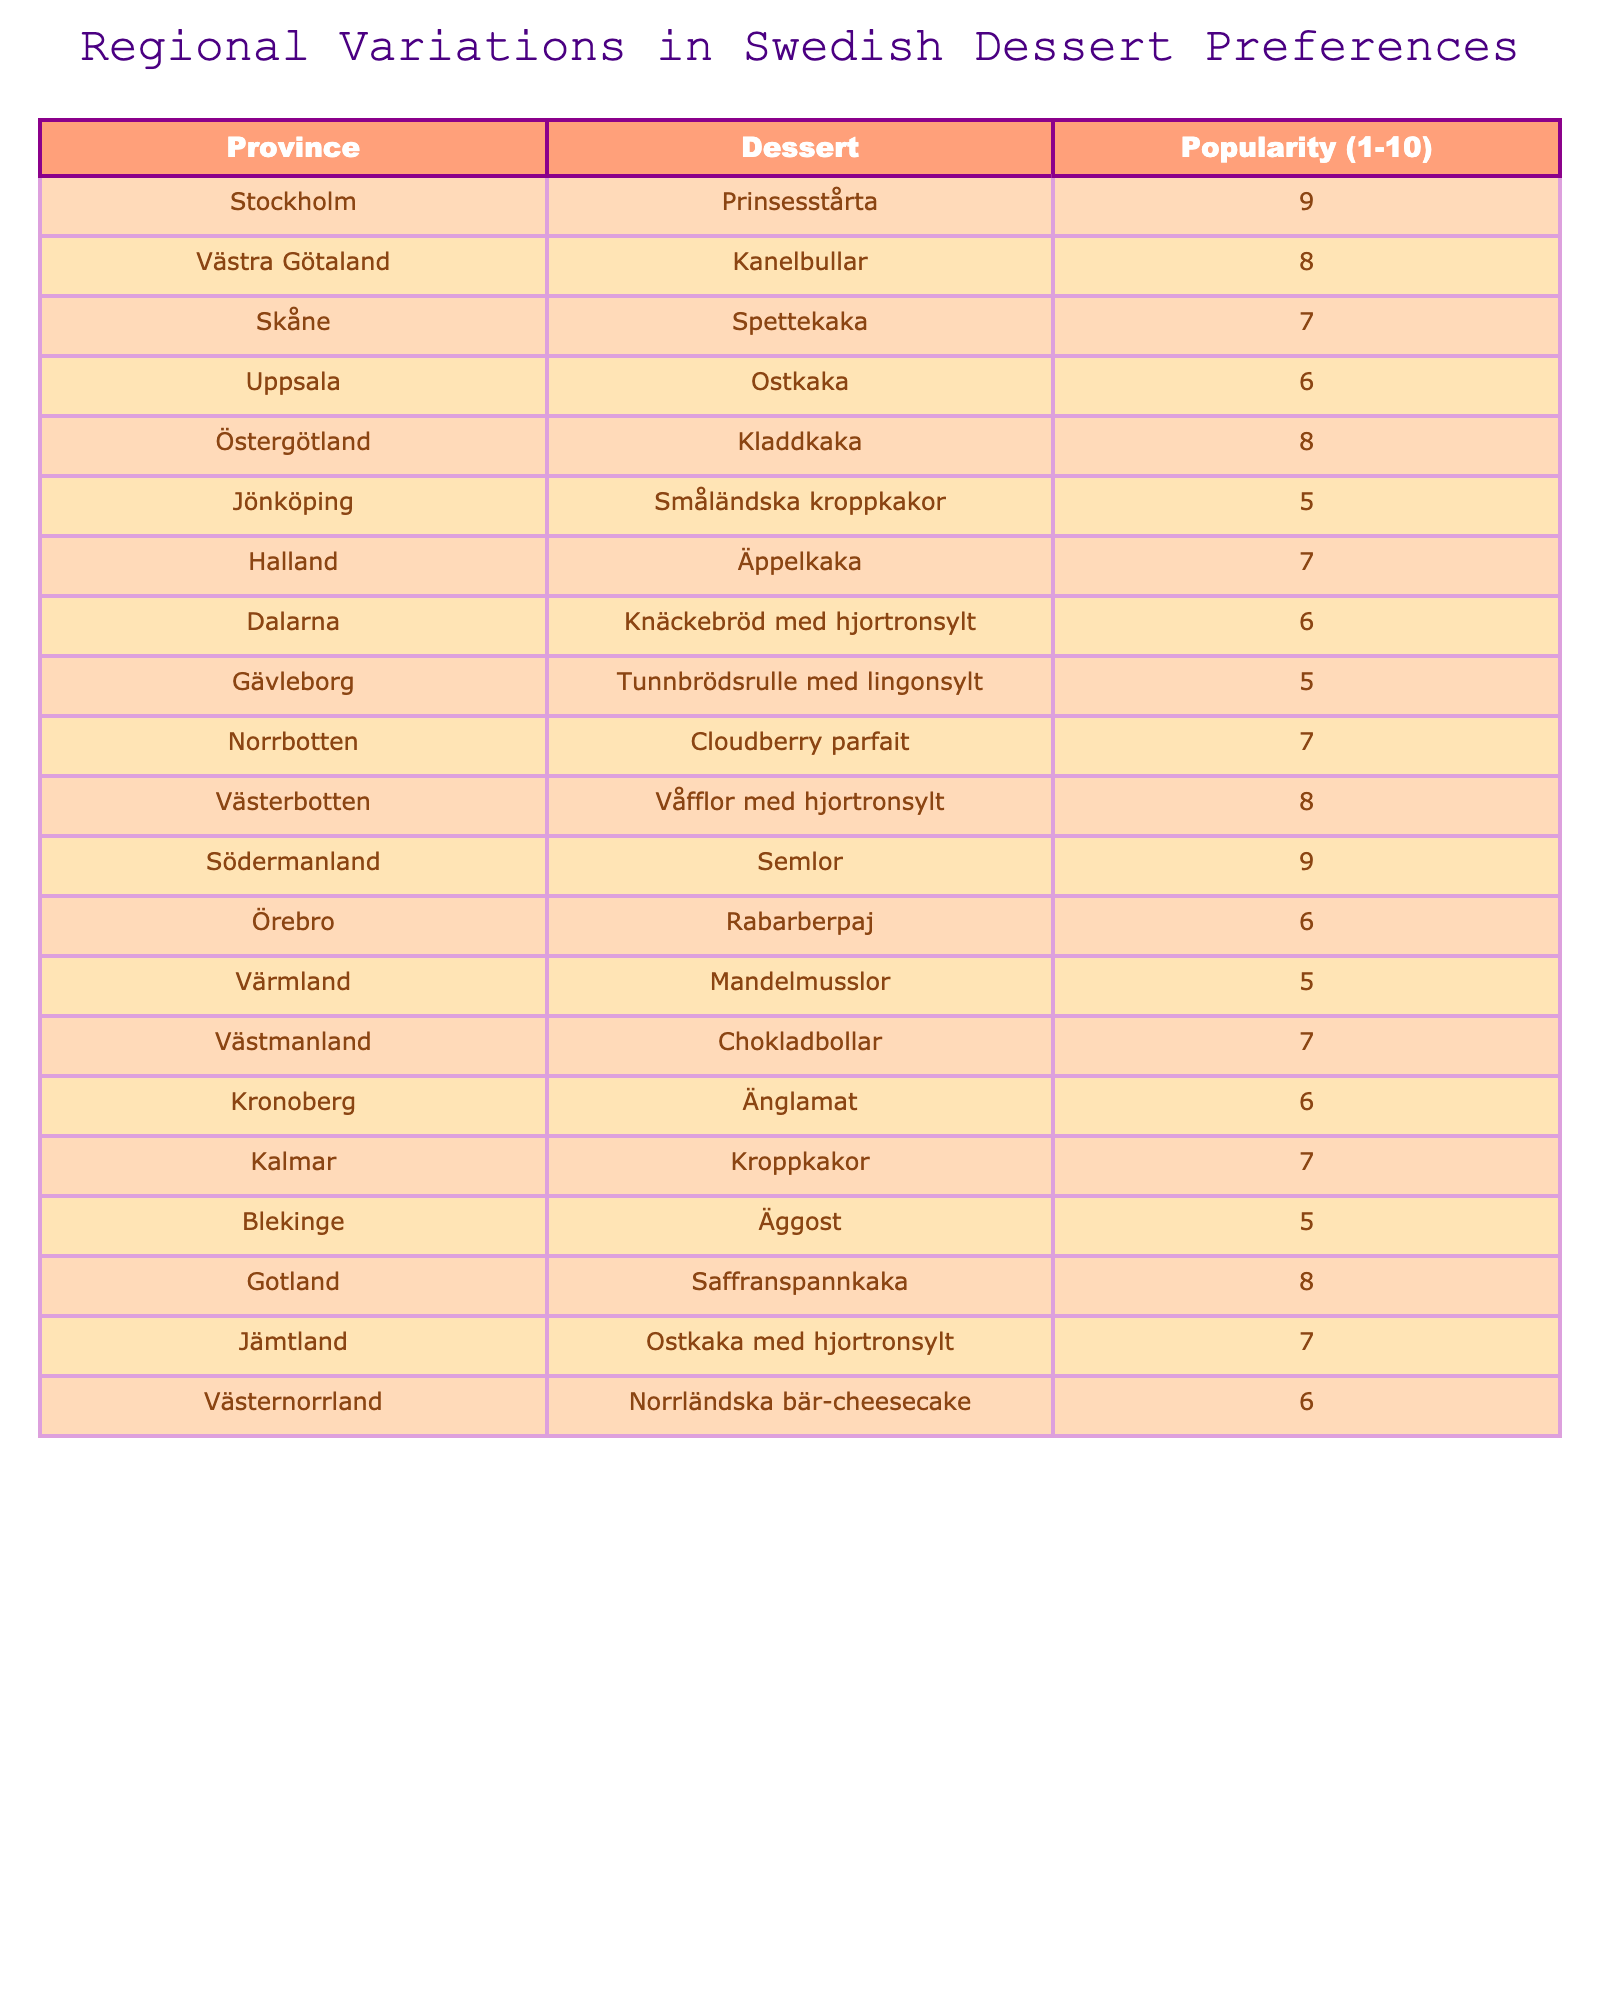What is the highest popularity score among Swedish desserts? The highest score listed in the table is 9, associated with Prinsesstårta and Semlor.
Answer: 9 Which province has the lowest popularity for dessert? By examining the table, I can see that Blekinge, Gävleborg, Jönköping, and Värmland each have a popularity score of 5, which is the lowest in the table.
Answer: 5 How many provinces have a dessert popularity score of 8? The provinces with a score of 8 are Västra Götaland, Östergötland, Västerbotten, and Gotland. There are 4 such provinces in total.
Answer: 4 What dessert is the most popular in Södermanland? According to the table, the most popular dessert in Södermanland is Semlor, with a popularity score of 9.
Answer: Semlor What is the average popularity score of all the desserts listed? To calculate the average, I will sum all popularity scores (9 + 8 + 7 + 6 + 8 + 5 + 7 + 6 + 5 + 7 + 8 + 9 + 6 + 5 + 7 + 6 + 7 + 6) which equals 122, and divide by the total number of desserts (18). The average is 122/18 = 6.78.
Answer: 6.78 Is there a dessert that is equally popular in more than one province? Yes, there are two desserts: Ostkaka has a popularity score of 6 in Uppsala, and Spettekaka has a score of 7 in Skåne, but they appear in only one province each, thus no dessert shares popularity across provinces.
Answer: No How many different desserts have a popularity score of 6? The table indicates that there are 4 different desserts with a popularity score of 6, which are Ostkaka, Rabarberpaj, Kronoberg's Änglamat, and Västernorrland's dessert.
Answer: 4 Calculate the difference in popularity between the highest and lowest scoring desserts. The highest popularity score is 9 (Prinsesstårta or Semlor), and the lowest score is 5 (multiple desserts). The difference is 9 - 5 = 4.
Answer: 4 What is the total popularity score for desserts from Norrbotten and Västerbotten combined? The score for Norrbotten is 7 (Cloudberry parfait), and for Västerbotten, it's 8 (Våfflor med hjortronsylt). Their combined score is 7 + 8 = 15.
Answer: 15 Which province has a dessert rated 7 and what is the dessert? The provinces with desserts rated 7 are Halland with Äppelkaka, Skåne with Spettekaka, Dalarna with Knäckebröd med hjortronsylt, Kalmar with Kroppkakor, and Västmanland with Chokladbollar.
Answer: Halland: Äppelkaka, Skåne: Spettekaka, Dalarna: Knäckebröd med hjortronsylt, Kalmar: Kroppkakor, Västmanland: Chokladbollar 